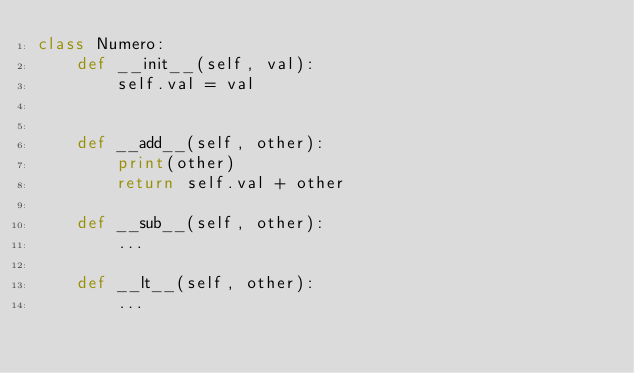Convert code to text. <code><loc_0><loc_0><loc_500><loc_500><_Python_>class Numero:
    def __init__(self, val):
        self.val = val


    def __add__(self, other):
        print(other)
        return self.val + other

    def __sub__(self, other):
        ...

    def __lt__(self, other):
        ...

</code> 